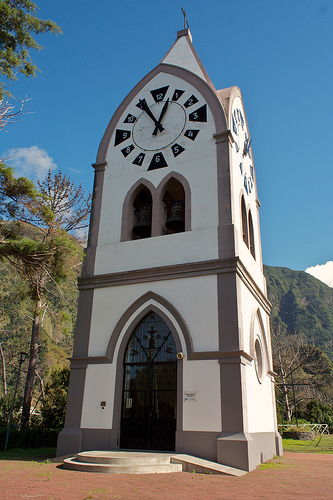What is the tower in front of? The tower is positioned in front of a hill. 